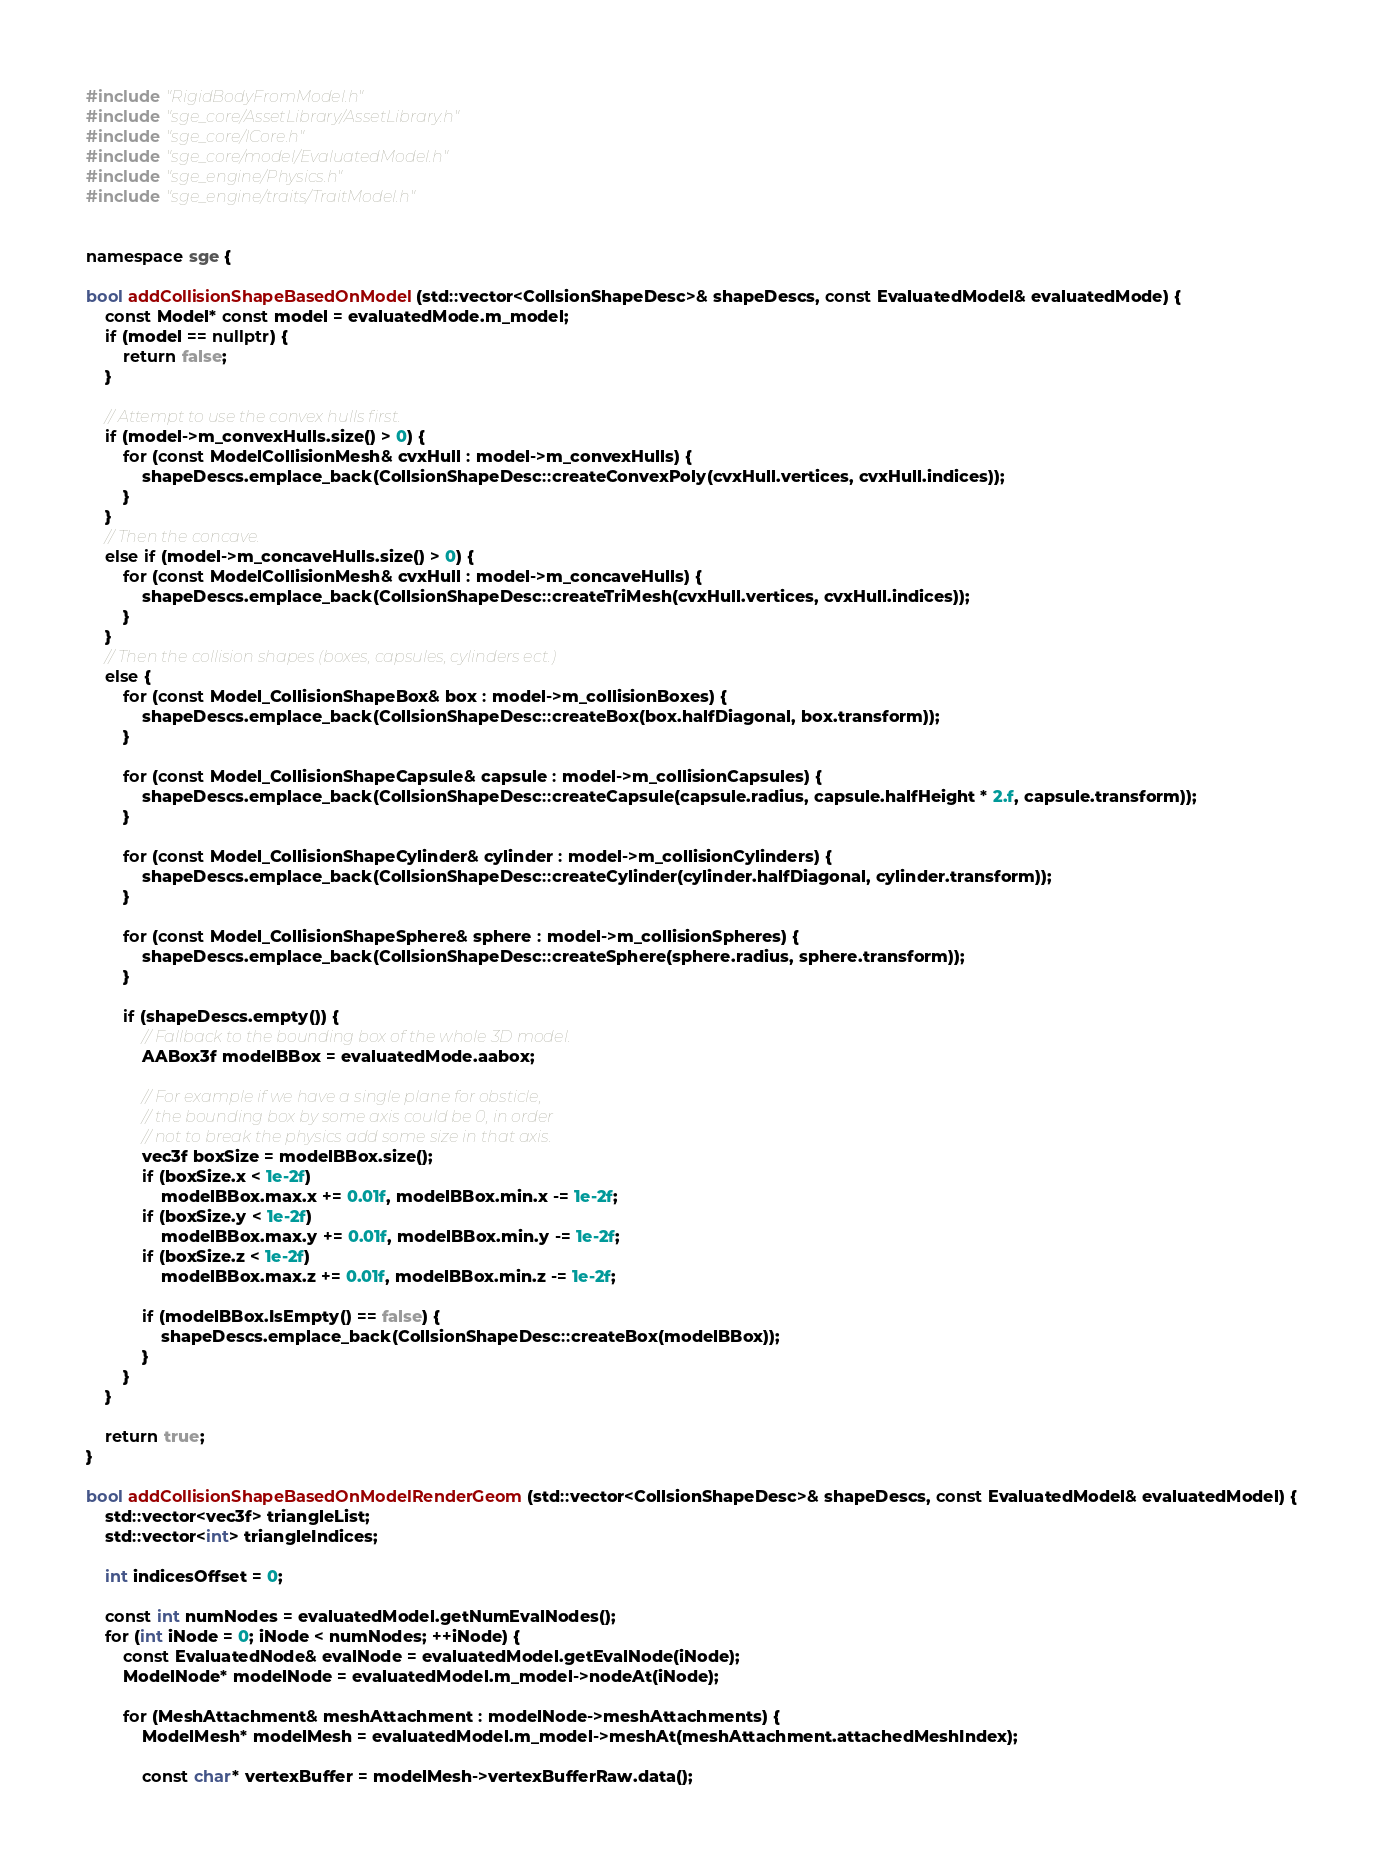Convert code to text. <code><loc_0><loc_0><loc_500><loc_500><_C++_>#include "RigidBodyFromModel.h"
#include "sge_core/AssetLibrary/AssetLibrary.h"
#include "sge_core/ICore.h"
#include "sge_core/model/EvaluatedModel.h"
#include "sge_engine/Physics.h"
#include "sge_engine/traits/TraitModel.h"


namespace sge {

bool addCollisionShapeBasedOnModel(std::vector<CollsionShapeDesc>& shapeDescs, const EvaluatedModel& evaluatedMode) {
	const Model* const model = evaluatedMode.m_model;
	if (model == nullptr) {
		return false;
	}

	// Attempt to use the convex hulls first.
	if (model->m_convexHulls.size() > 0) {
		for (const ModelCollisionMesh& cvxHull : model->m_convexHulls) {
			shapeDescs.emplace_back(CollsionShapeDesc::createConvexPoly(cvxHull.vertices, cvxHull.indices));
		}
	}
	// Then the concave.
	else if (model->m_concaveHulls.size() > 0) {
		for (const ModelCollisionMesh& cvxHull : model->m_concaveHulls) {
			shapeDescs.emplace_back(CollsionShapeDesc::createTriMesh(cvxHull.vertices, cvxHull.indices));
		}
	}
	// Then the collision shapes (boxes, capsules, cylinders ect.)
	else {
		for (const Model_CollisionShapeBox& box : model->m_collisionBoxes) {
			shapeDescs.emplace_back(CollsionShapeDesc::createBox(box.halfDiagonal, box.transform));
		}

		for (const Model_CollisionShapeCapsule& capsule : model->m_collisionCapsules) {
			shapeDescs.emplace_back(CollsionShapeDesc::createCapsule(capsule.radius, capsule.halfHeight * 2.f, capsule.transform));
		}

		for (const Model_CollisionShapeCylinder& cylinder : model->m_collisionCylinders) {
			shapeDescs.emplace_back(CollsionShapeDesc::createCylinder(cylinder.halfDiagonal, cylinder.transform));
		}

		for (const Model_CollisionShapeSphere& sphere : model->m_collisionSpheres) {
			shapeDescs.emplace_back(CollsionShapeDesc::createSphere(sphere.radius, sphere.transform));
		}

		if (shapeDescs.empty()) {
			// Fallback to the bounding box of the whole 3D model.
			AABox3f modelBBox = evaluatedMode.aabox;

			// For example if we have a single plane for obsticle,
			// the bounding box by some axis could be 0, in order
			// not to break the physics add some size in that axis.
			vec3f boxSize = modelBBox.size();
			if (boxSize.x < 1e-2f)
				modelBBox.max.x += 0.01f, modelBBox.min.x -= 1e-2f;
			if (boxSize.y < 1e-2f)
				modelBBox.max.y += 0.01f, modelBBox.min.y -= 1e-2f;
			if (boxSize.z < 1e-2f)
				modelBBox.max.z += 0.01f, modelBBox.min.z -= 1e-2f;

			if (modelBBox.IsEmpty() == false) {
				shapeDescs.emplace_back(CollsionShapeDesc::createBox(modelBBox));
			}
		}
	}

	return true;
}

bool addCollisionShapeBasedOnModelRenderGeom(std::vector<CollsionShapeDesc>& shapeDescs, const EvaluatedModel& evaluatedModel) {
	std::vector<vec3f> triangleList;
	std::vector<int> triangleIndices;

	int indicesOffset = 0;

	const int numNodes = evaluatedModel.getNumEvalNodes();
	for (int iNode = 0; iNode < numNodes; ++iNode) {
		const EvaluatedNode& evalNode = evaluatedModel.getEvalNode(iNode);
		ModelNode* modelNode = evaluatedModel.m_model->nodeAt(iNode);

		for (MeshAttachment& meshAttachment : modelNode->meshAttachments) {
			ModelMesh* modelMesh = evaluatedModel.m_model->meshAt(meshAttachment.attachedMeshIndex);

			const char* vertexBuffer = modelMesh->vertexBufferRaw.data();</code> 